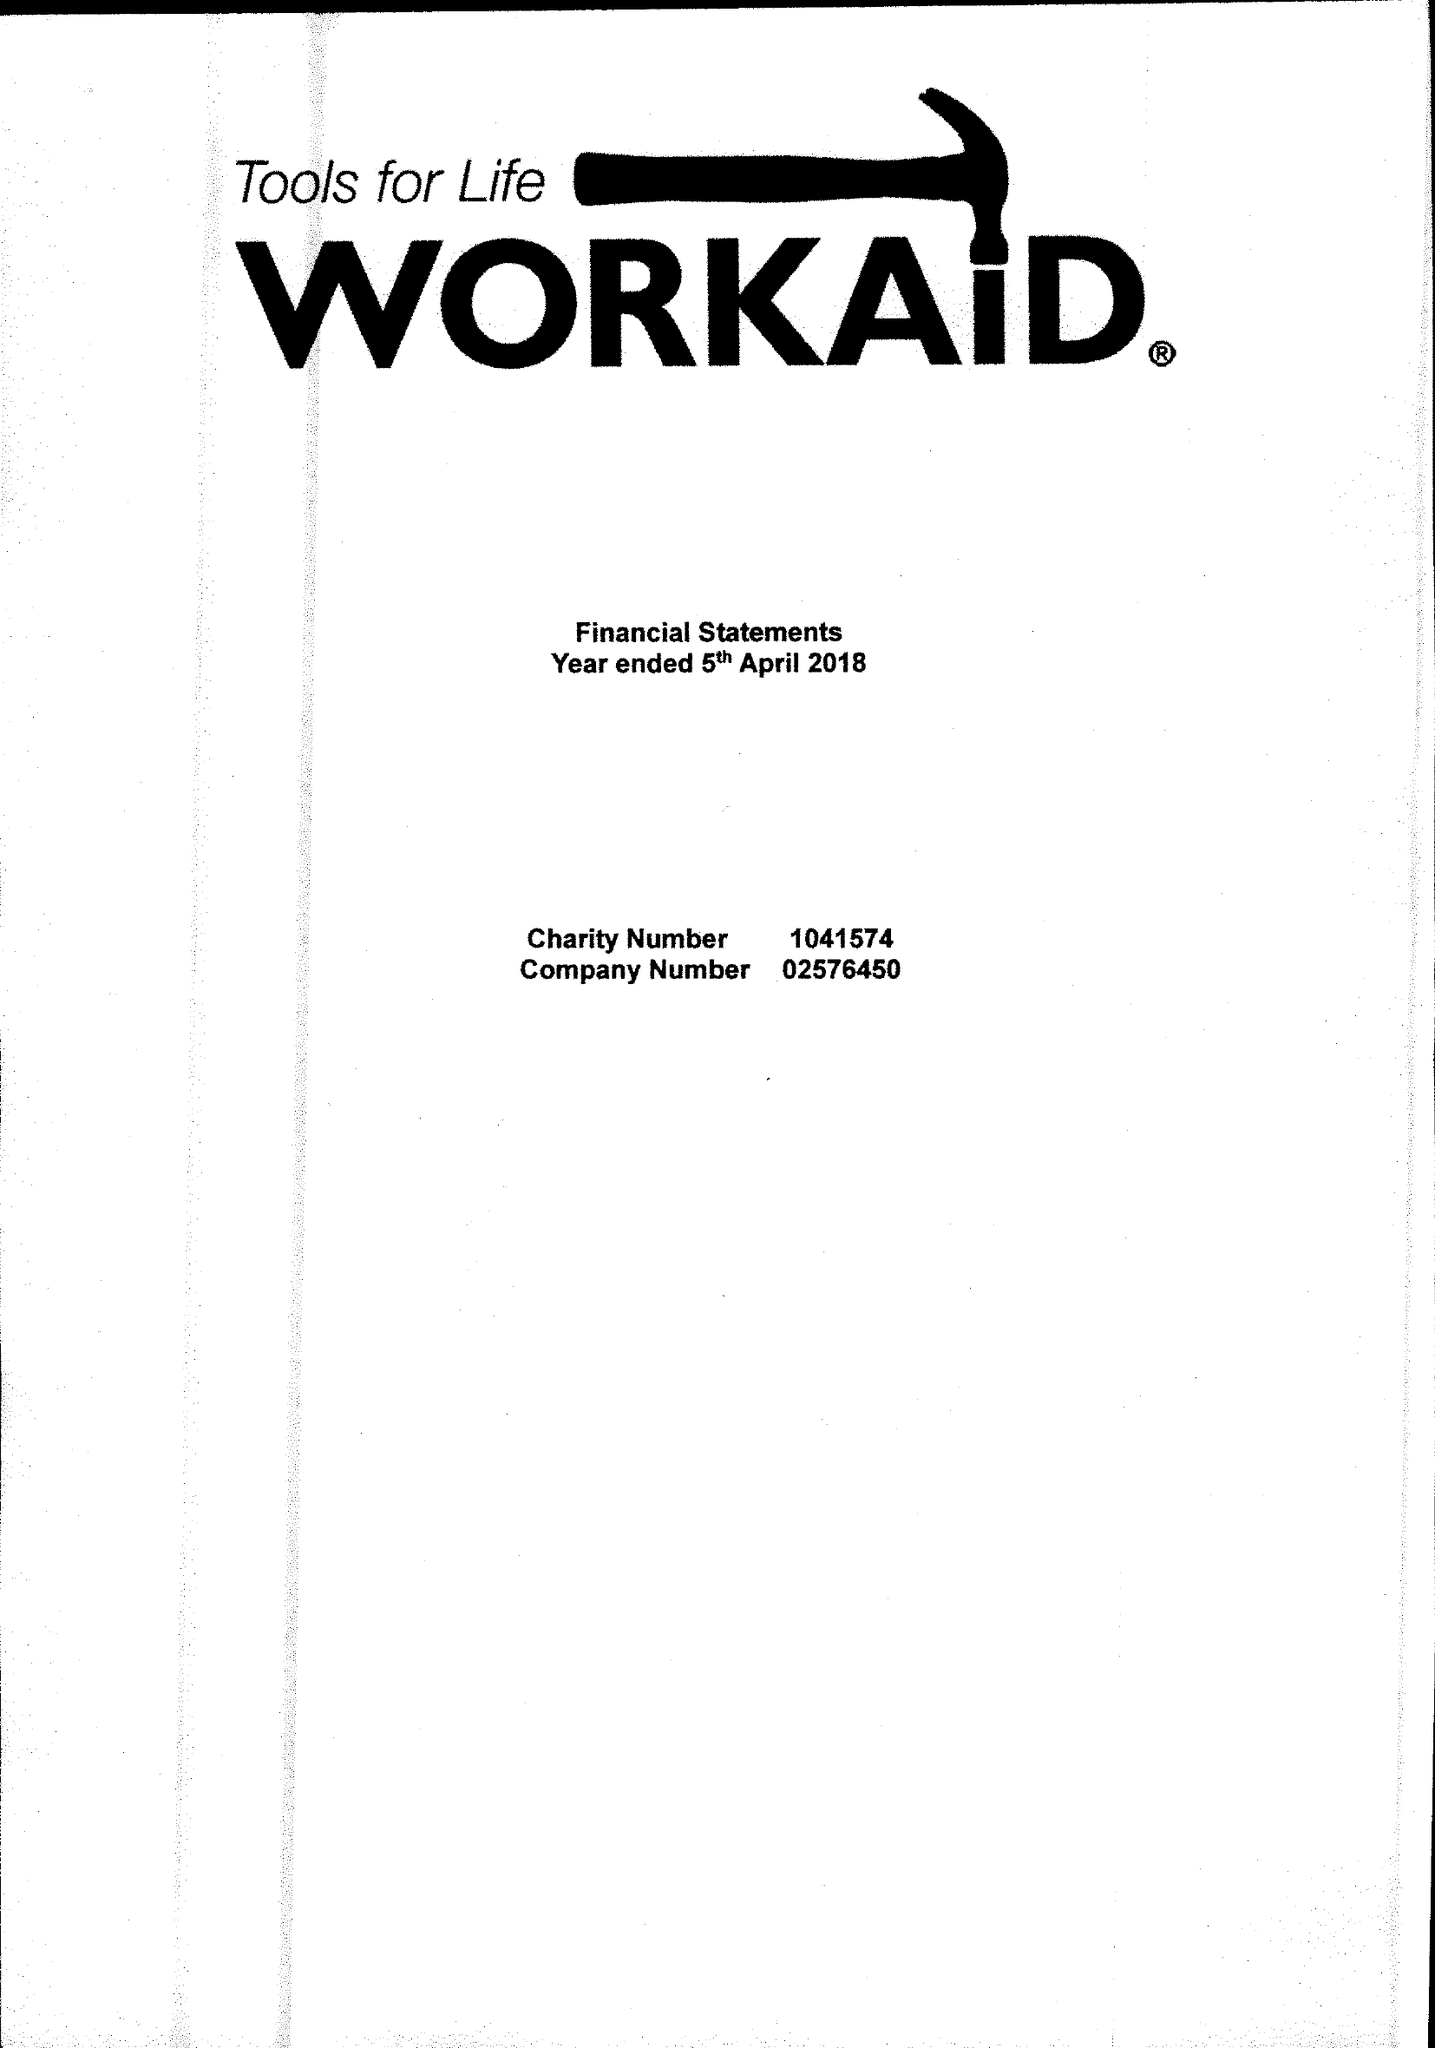What is the value for the charity_name?
Answer the question using a single word or phrase. Workaid 